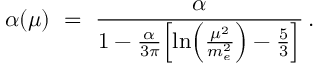<formula> <loc_0><loc_0><loc_500><loc_500>\alpha ( \mu ) \ = \ { \frac { \alpha } { 1 - { \frac { \alpha } { 3 \pi } } \left [ \ln \left ( { \frac { \mu ^ { 2 } } { m _ { e } ^ { 2 } } } \right ) - { \frac { 5 } { 3 } } \right ] } } \, .</formula> 